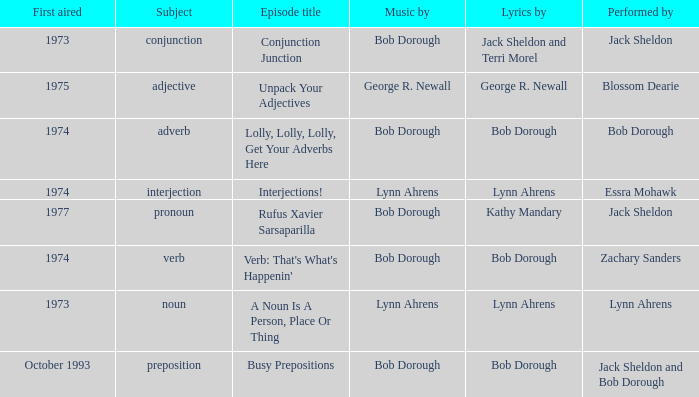When zachary sanders is the performer how many people is the music by? 1.0. 